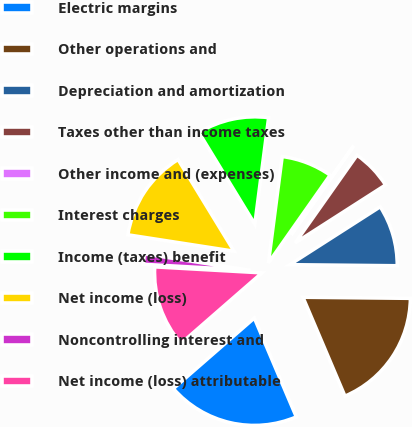Convert chart to OTSL. <chart><loc_0><loc_0><loc_500><loc_500><pie_chart><fcel>Electric margins<fcel>Other operations and<fcel>Depreciation and amortization<fcel>Taxes other than income taxes<fcel>Other income and (expenses)<fcel>Interest charges<fcel>Income (taxes) benefit<fcel>Net income (loss)<fcel>Noncontrolling interest and<fcel>Net income (loss) attributable<nl><fcel>19.98%<fcel>18.45%<fcel>9.23%<fcel>6.16%<fcel>0.02%<fcel>7.7%<fcel>10.77%<fcel>13.84%<fcel>1.55%<fcel>12.3%<nl></chart> 